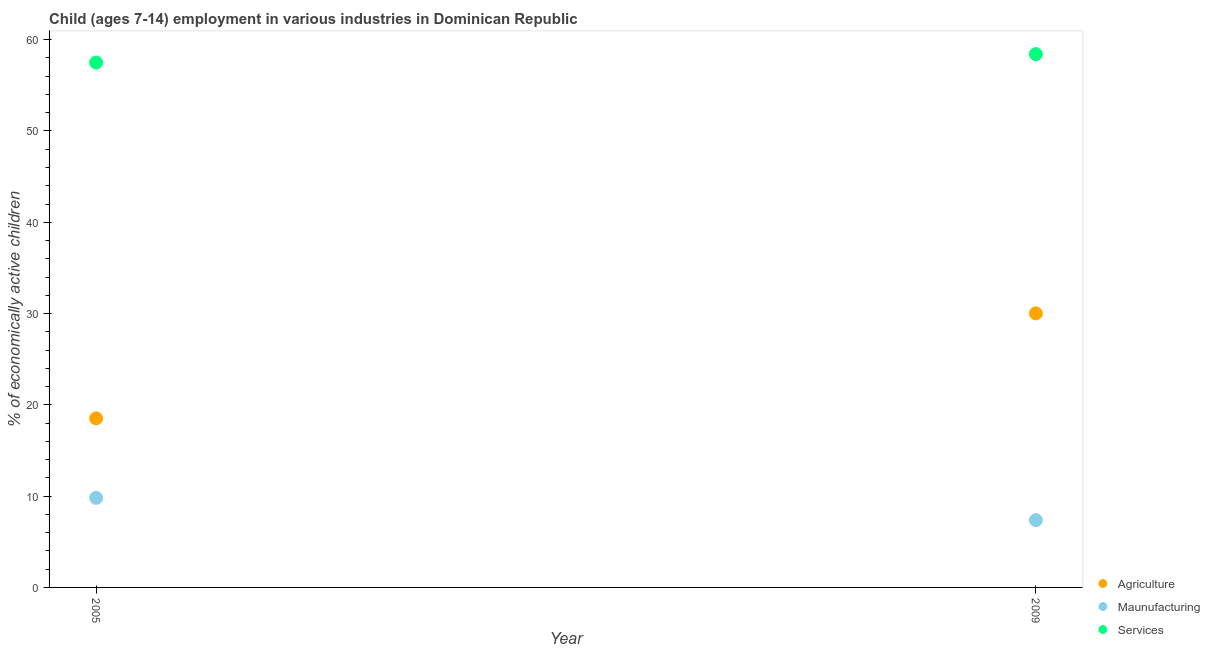How many different coloured dotlines are there?
Offer a very short reply. 3. Is the number of dotlines equal to the number of legend labels?
Offer a terse response. Yes. What is the percentage of economically active children in services in 2009?
Your answer should be compact. 58.42. Across all years, what is the maximum percentage of economically active children in services?
Your answer should be very brief. 58.42. Across all years, what is the minimum percentage of economically active children in manufacturing?
Provide a short and direct response. 7.37. What is the total percentage of economically active children in services in the graph?
Your answer should be very brief. 115.92. What is the difference between the percentage of economically active children in manufacturing in 2005 and that in 2009?
Your answer should be very brief. 2.44. What is the difference between the percentage of economically active children in agriculture in 2005 and the percentage of economically active children in manufacturing in 2009?
Your response must be concise. 11.15. What is the average percentage of economically active children in services per year?
Your response must be concise. 57.96. In the year 2009, what is the difference between the percentage of economically active children in agriculture and percentage of economically active children in manufacturing?
Make the answer very short. 22.65. In how many years, is the percentage of economically active children in services greater than 6 %?
Make the answer very short. 2. What is the ratio of the percentage of economically active children in agriculture in 2005 to that in 2009?
Give a very brief answer. 0.62. Is the percentage of economically active children in services in 2005 less than that in 2009?
Provide a short and direct response. Yes. In how many years, is the percentage of economically active children in agriculture greater than the average percentage of economically active children in agriculture taken over all years?
Provide a short and direct response. 1. How many dotlines are there?
Ensure brevity in your answer.  3. How many years are there in the graph?
Your answer should be very brief. 2. What is the difference between two consecutive major ticks on the Y-axis?
Your response must be concise. 10. Does the graph contain grids?
Your answer should be very brief. No. Where does the legend appear in the graph?
Your response must be concise. Bottom right. What is the title of the graph?
Keep it short and to the point. Child (ages 7-14) employment in various industries in Dominican Republic. Does "Total employers" appear as one of the legend labels in the graph?
Provide a succinct answer. No. What is the label or title of the Y-axis?
Your answer should be compact. % of economically active children. What is the % of economically active children in Agriculture in 2005?
Offer a very short reply. 18.52. What is the % of economically active children of Maunufacturing in 2005?
Provide a succinct answer. 9.81. What is the % of economically active children of Services in 2005?
Your response must be concise. 57.5. What is the % of economically active children of Agriculture in 2009?
Give a very brief answer. 30.02. What is the % of economically active children of Maunufacturing in 2009?
Keep it short and to the point. 7.37. What is the % of economically active children of Services in 2009?
Keep it short and to the point. 58.42. Across all years, what is the maximum % of economically active children in Agriculture?
Provide a short and direct response. 30.02. Across all years, what is the maximum % of economically active children of Maunufacturing?
Offer a very short reply. 9.81. Across all years, what is the maximum % of economically active children of Services?
Provide a succinct answer. 58.42. Across all years, what is the minimum % of economically active children of Agriculture?
Provide a short and direct response. 18.52. Across all years, what is the minimum % of economically active children of Maunufacturing?
Offer a very short reply. 7.37. Across all years, what is the minimum % of economically active children of Services?
Provide a succinct answer. 57.5. What is the total % of economically active children of Agriculture in the graph?
Provide a short and direct response. 48.54. What is the total % of economically active children of Maunufacturing in the graph?
Keep it short and to the point. 17.18. What is the total % of economically active children of Services in the graph?
Provide a succinct answer. 115.92. What is the difference between the % of economically active children in Agriculture in 2005 and that in 2009?
Provide a short and direct response. -11.5. What is the difference between the % of economically active children in Maunufacturing in 2005 and that in 2009?
Provide a short and direct response. 2.44. What is the difference between the % of economically active children in Services in 2005 and that in 2009?
Offer a very short reply. -0.92. What is the difference between the % of economically active children of Agriculture in 2005 and the % of economically active children of Maunufacturing in 2009?
Provide a short and direct response. 11.15. What is the difference between the % of economically active children of Agriculture in 2005 and the % of economically active children of Services in 2009?
Offer a very short reply. -39.9. What is the difference between the % of economically active children in Maunufacturing in 2005 and the % of economically active children in Services in 2009?
Give a very brief answer. -48.61. What is the average % of economically active children of Agriculture per year?
Ensure brevity in your answer.  24.27. What is the average % of economically active children of Maunufacturing per year?
Make the answer very short. 8.59. What is the average % of economically active children in Services per year?
Your answer should be very brief. 57.96. In the year 2005, what is the difference between the % of economically active children of Agriculture and % of economically active children of Maunufacturing?
Provide a short and direct response. 8.71. In the year 2005, what is the difference between the % of economically active children of Agriculture and % of economically active children of Services?
Make the answer very short. -38.98. In the year 2005, what is the difference between the % of economically active children in Maunufacturing and % of economically active children in Services?
Keep it short and to the point. -47.69. In the year 2009, what is the difference between the % of economically active children in Agriculture and % of economically active children in Maunufacturing?
Your response must be concise. 22.65. In the year 2009, what is the difference between the % of economically active children of Agriculture and % of economically active children of Services?
Your response must be concise. -28.4. In the year 2009, what is the difference between the % of economically active children of Maunufacturing and % of economically active children of Services?
Offer a terse response. -51.05. What is the ratio of the % of economically active children in Agriculture in 2005 to that in 2009?
Give a very brief answer. 0.62. What is the ratio of the % of economically active children of Maunufacturing in 2005 to that in 2009?
Ensure brevity in your answer.  1.33. What is the ratio of the % of economically active children of Services in 2005 to that in 2009?
Offer a terse response. 0.98. What is the difference between the highest and the second highest % of economically active children of Agriculture?
Keep it short and to the point. 11.5. What is the difference between the highest and the second highest % of economically active children in Maunufacturing?
Make the answer very short. 2.44. What is the difference between the highest and the lowest % of economically active children in Agriculture?
Give a very brief answer. 11.5. What is the difference between the highest and the lowest % of economically active children of Maunufacturing?
Your response must be concise. 2.44. 